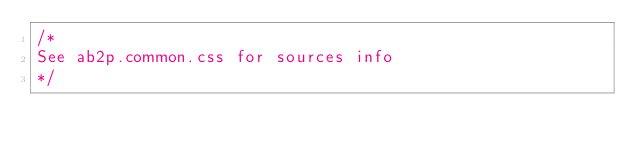Convert code to text. <code><loc_0><loc_0><loc_500><loc_500><_CSS_>/*
See ab2p.common.css for sources info
*/</code> 